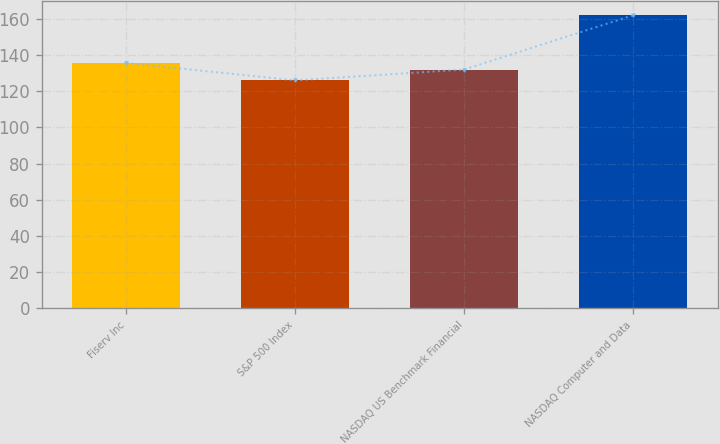Convert chart to OTSL. <chart><loc_0><loc_0><loc_500><loc_500><bar_chart><fcel>Fiserv Inc<fcel>S&P 500 Index<fcel>NASDAQ US Benchmark Financial<fcel>NASDAQ Computer and Data<nl><fcel>135.6<fcel>126<fcel>132<fcel>162<nl></chart> 